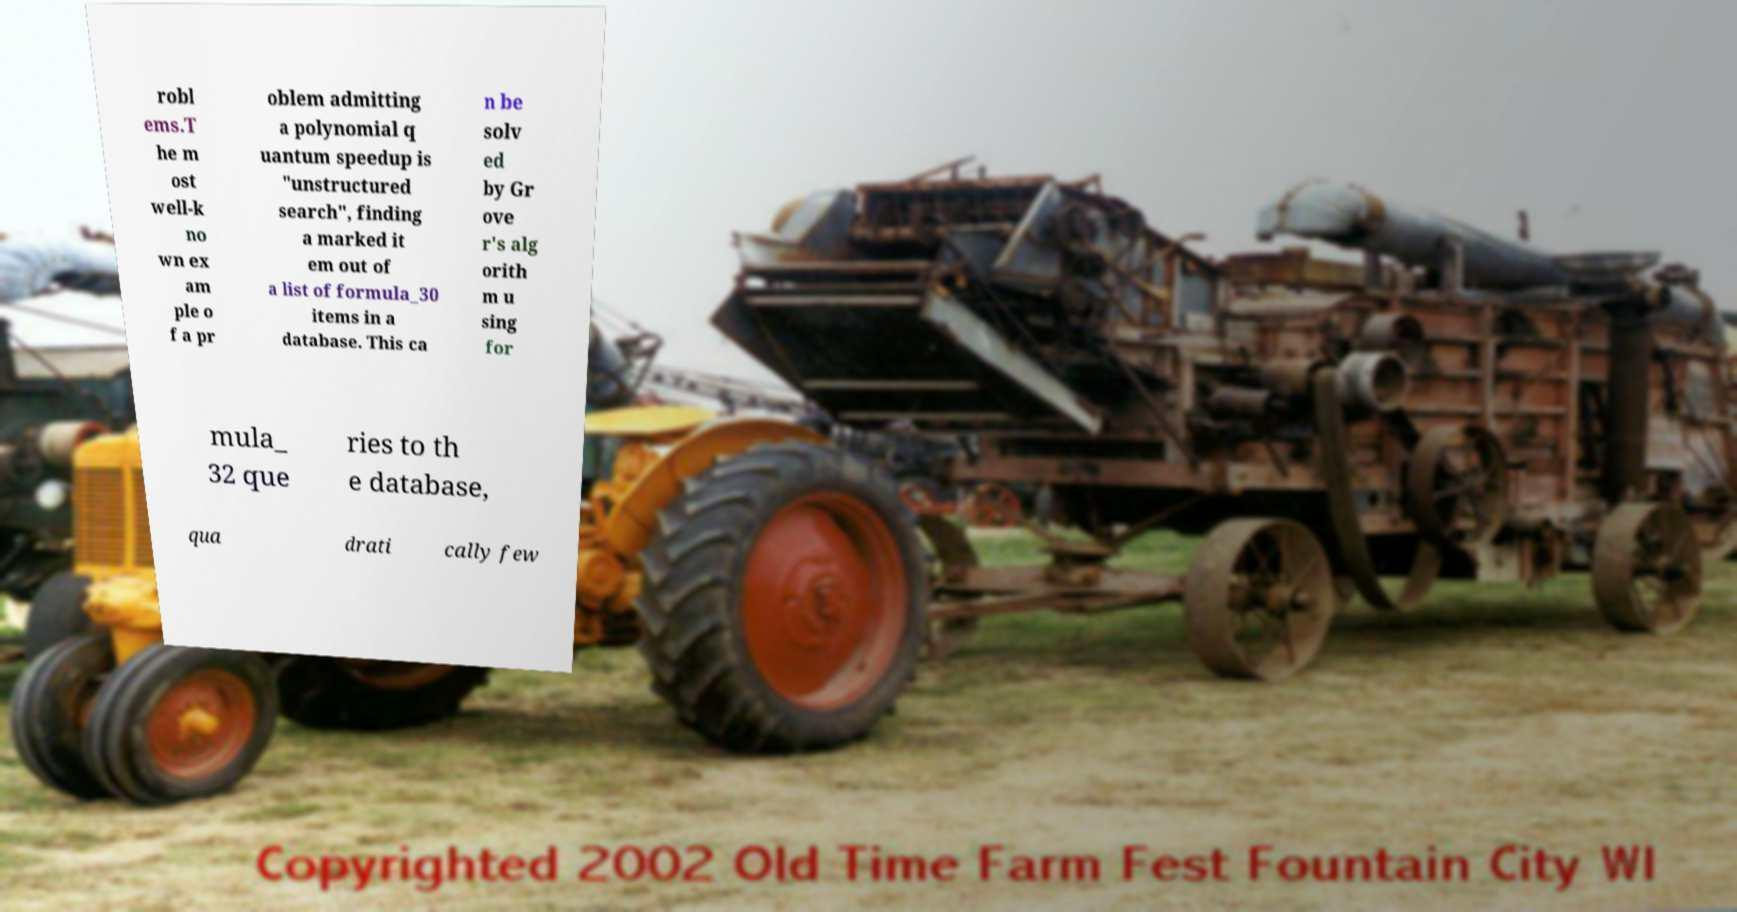Can you accurately transcribe the text from the provided image for me? robl ems.T he m ost well-k no wn ex am ple o f a pr oblem admitting a polynomial q uantum speedup is "unstructured search", finding a marked it em out of a list of formula_30 items in a database. This ca n be solv ed by Gr ove r's alg orith m u sing for mula_ 32 que ries to th e database, qua drati cally few 